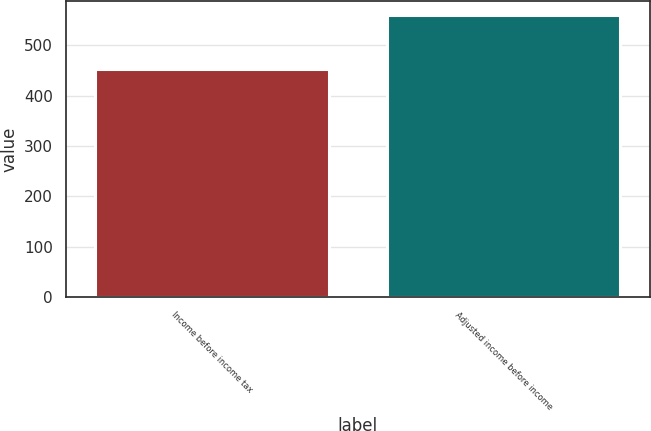Convert chart. <chart><loc_0><loc_0><loc_500><loc_500><bar_chart><fcel>Income before income tax<fcel>Adjusted income before income<nl><fcel>452<fcel>559<nl></chart> 